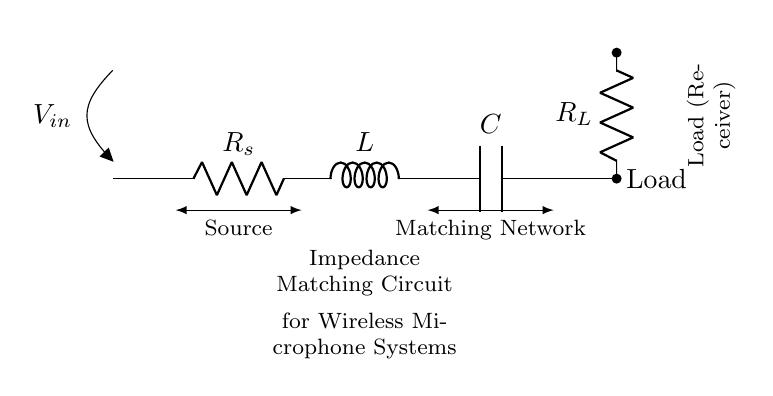What is the source resistance in this circuit? The source resistance is denoted as R_s in the circuit diagram, identified as the first component in the impedance matching network.
Answer: R_s What type of components are used in this circuit? The circuit contains a resistor, an inductor, and a capacitor, which are standard components in an RLC circuit.
Answer: Resistor, inductor, capacitor What is the purpose of this circuit? The purpose is to match the impedance for wireless microphone systems, ensuring maximum power transfer and minimizing signal reflection.
Answer: Impedance matching What is the load resistance in this circuit? The load resistance is indicated as R_L, located at the end of the circuit connected to the load (receiver).
Answer: R_L What happens to the signal if the impedance is mismatched? A mismatch leads to signal reflections, which can cause distortion and reduce the efficiency of the system.
Answer: Signal distortion How does the inductance in this circuit affect the overall impedance? The inductance contributes to the overall impedance by introducing a reactive element that varies with frequency, potentially impacting resonance in the circuit.
Answer: Varies with frequency 